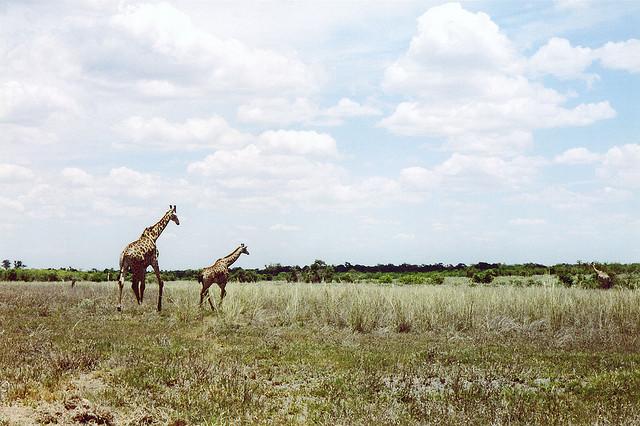Where are the two tall trees?
Concise answer only. Left. Can you see the sun?
Be succinct. No. Are the giraffes out in the wild?
Short answer required. Yes. What are the giraffes doing?
Give a very brief answer. Walking. 